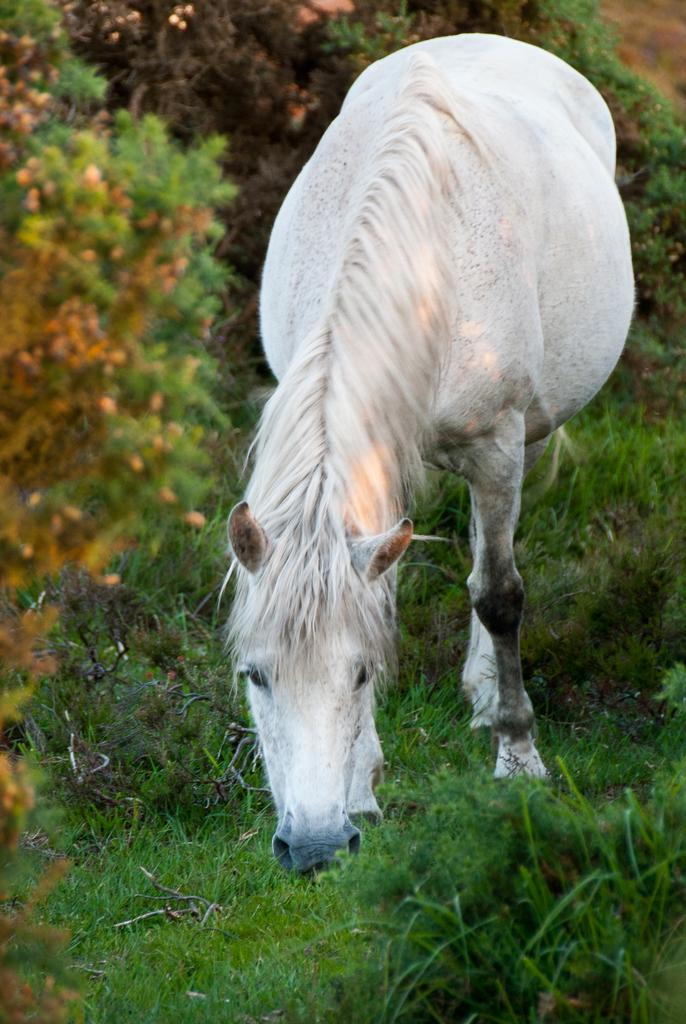What type of animal is in the image? There is a white horse in the image. Where is the horse located? The horse is on a grassy land. How is the horse positioned in the image? The horse is in the middle of the image. What can be seen in the background of the image? There are plants in the background of the image. What type of hair is visible on the horse's body in the image? There is no mention of the horse's hair in the provided facts, so it cannot be determined from the image. 